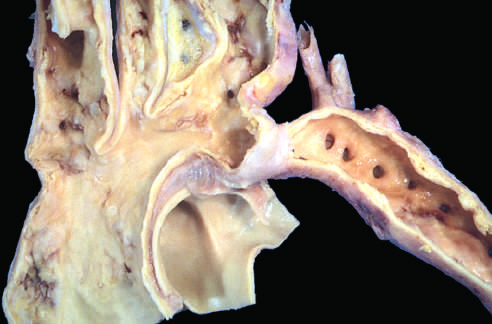what is the coarctation of the aorta?
Answer the question using a single word or phrase. Segmental narrowing 